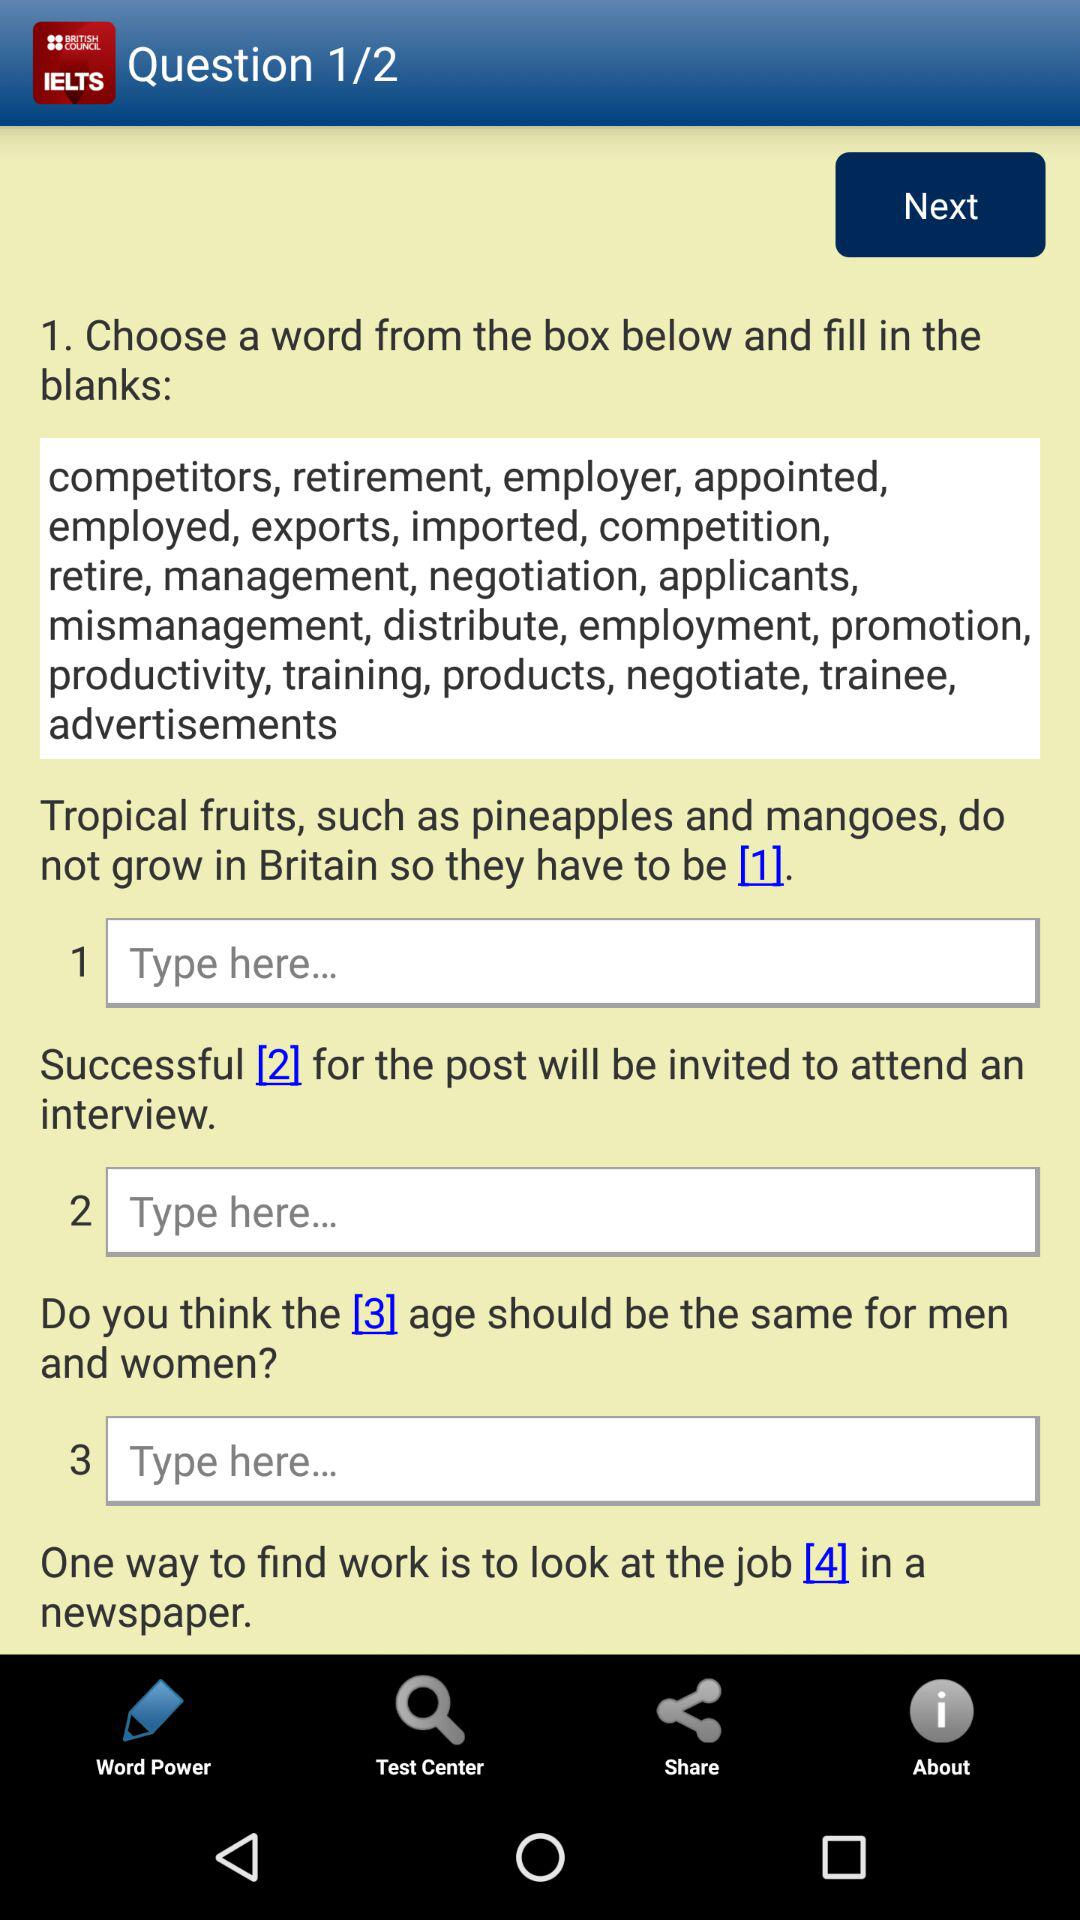how many questions in total are there? There are two questions. 